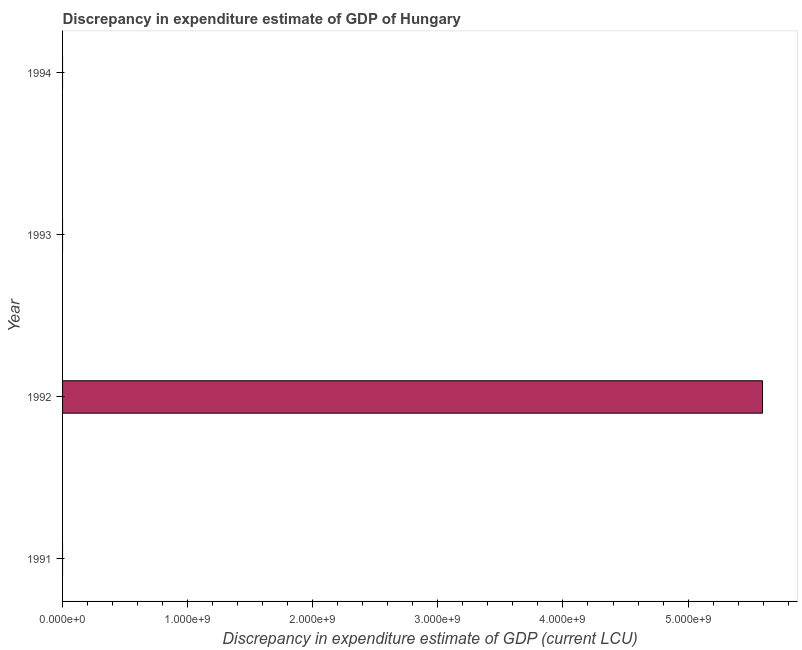Does the graph contain grids?
Your response must be concise. No. What is the title of the graph?
Give a very brief answer. Discrepancy in expenditure estimate of GDP of Hungary. What is the label or title of the X-axis?
Your answer should be very brief. Discrepancy in expenditure estimate of GDP (current LCU). What is the discrepancy in expenditure estimate of gdp in 1992?
Keep it short and to the point. 5.60e+09. Across all years, what is the maximum discrepancy in expenditure estimate of gdp?
Make the answer very short. 5.60e+09. Across all years, what is the minimum discrepancy in expenditure estimate of gdp?
Your answer should be compact. 0. In which year was the discrepancy in expenditure estimate of gdp maximum?
Provide a succinct answer. 1992. What is the sum of the discrepancy in expenditure estimate of gdp?
Ensure brevity in your answer.  5.60e+09. What is the average discrepancy in expenditure estimate of gdp per year?
Your answer should be compact. 1.40e+09. What is the median discrepancy in expenditure estimate of gdp?
Provide a succinct answer. 0. What is the difference between the highest and the lowest discrepancy in expenditure estimate of gdp?
Keep it short and to the point. 5.60e+09. In how many years, is the discrepancy in expenditure estimate of gdp greater than the average discrepancy in expenditure estimate of gdp taken over all years?
Provide a succinct answer. 1. How many bars are there?
Provide a short and direct response. 1. Are all the bars in the graph horizontal?
Offer a very short reply. Yes. What is the difference between two consecutive major ticks on the X-axis?
Offer a terse response. 1.00e+09. Are the values on the major ticks of X-axis written in scientific E-notation?
Make the answer very short. Yes. What is the Discrepancy in expenditure estimate of GDP (current LCU) in 1991?
Ensure brevity in your answer.  0. What is the Discrepancy in expenditure estimate of GDP (current LCU) of 1992?
Give a very brief answer. 5.60e+09. What is the Discrepancy in expenditure estimate of GDP (current LCU) in 1994?
Provide a succinct answer. 0. 